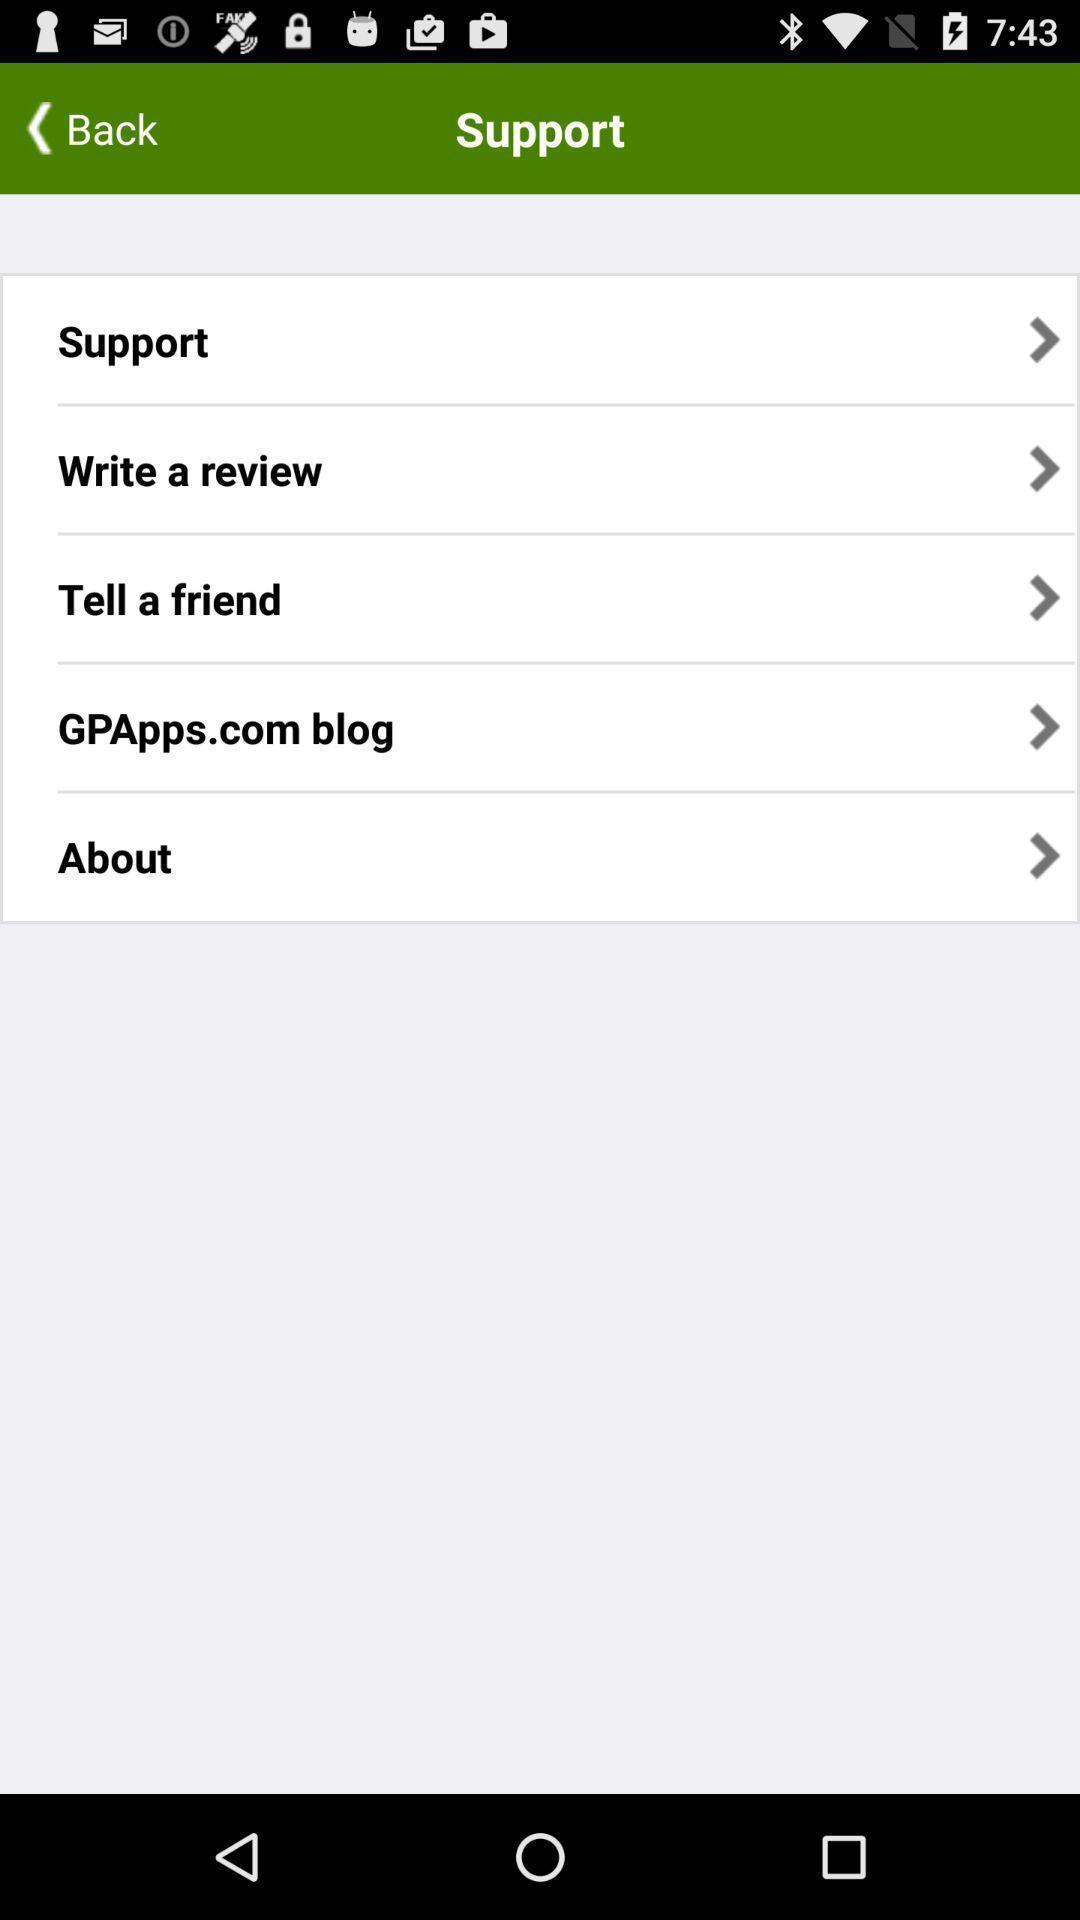Tell me about the visual elements in this screen capture. Screen shows different options. 